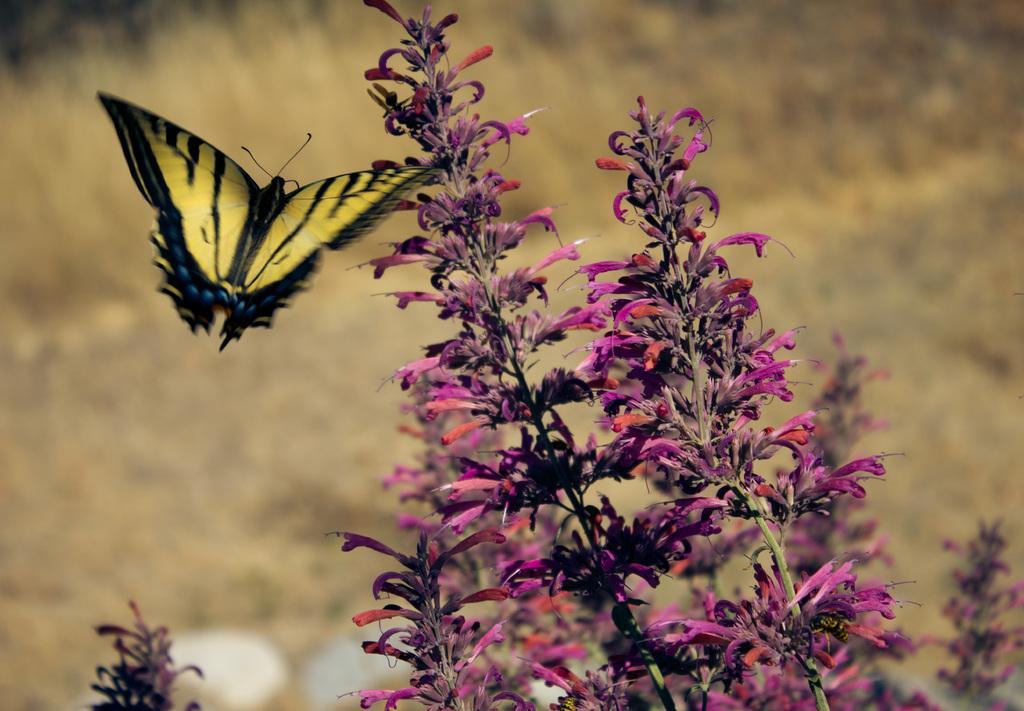Describe this image in one or two sentences. In this picture I can see there is a yellow color butterfly and there is a plant on to right side, it has flowers and buds. In the backdrop there is grass. 